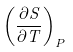Convert formula to latex. <formula><loc_0><loc_0><loc_500><loc_500>\left ( { \frac { \partial S } { \partial T } } \right ) _ { P }</formula> 